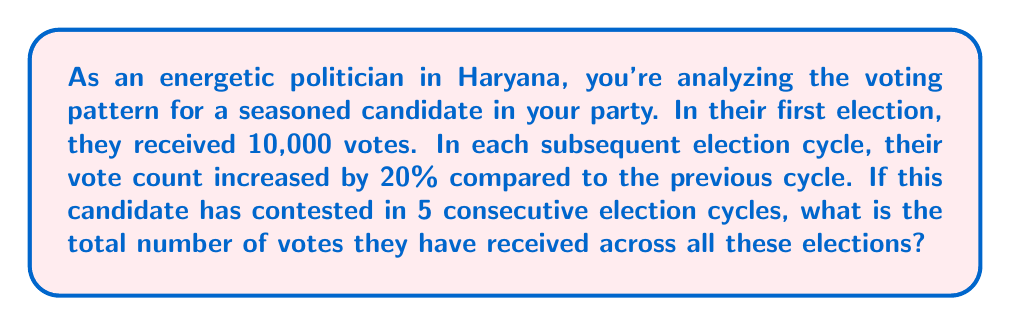Show me your answer to this math problem. Let's approach this step-by-step using the concept of geometric series:

1) First, let's identify our terms:
   - Initial term (first election): $a = 10,000$
   - Common ratio: $r = 1.20$ (20% increase = 1 + 0.20)
   - Number of terms: $n = 5$ (5 election cycles)

2) The votes in each election cycle form a geometric sequence:
   - 1st election: $10,000$
   - 2nd election: $10,000 \times 1.20 = 12,000$
   - 3rd election: $10,000 \times 1.20^2 = 14,400$
   - 4th election: $10,000 \times 1.20^3 = 17,280$
   - 5th election: $10,000 \times 1.20^4 = 20,736$

3) To find the sum of this geometric series, we use the formula:

   $$S_n = \frac{a(1-r^n)}{1-r}$$

   Where $S_n$ is the sum of the series, $a$ is the first term, $r$ is the common ratio, and $n$ is the number of terms.

4) Substituting our values:

   $$S_5 = \frac{10,000(1-1.20^5)}{1-1.20}$$

5) Simplify:
   $$S_5 = \frac{10,000(1-2.48832)}{-0.20}$$
   $$S_5 = \frac{10,000(-1.48832)}{-0.20}$$
   $$S_5 = 74,416$$

Therefore, the total number of votes received across all 5 election cycles is 74,416.
Answer: 74,416 votes 